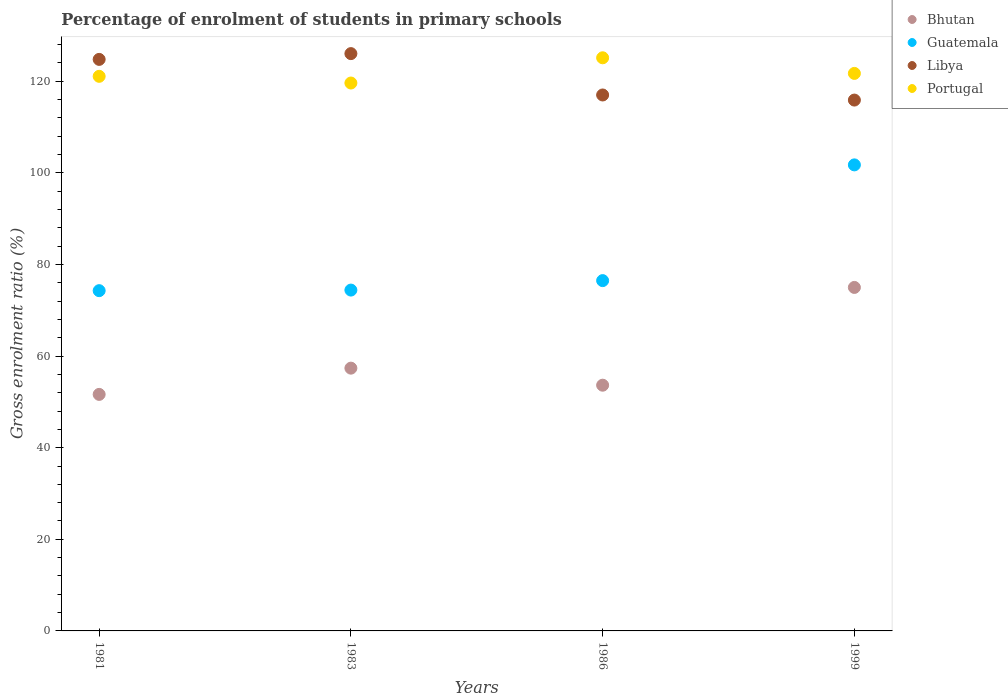How many different coloured dotlines are there?
Provide a succinct answer. 4. Is the number of dotlines equal to the number of legend labels?
Give a very brief answer. Yes. What is the percentage of students enrolled in primary schools in Bhutan in 1981?
Provide a short and direct response. 51.64. Across all years, what is the maximum percentage of students enrolled in primary schools in Libya?
Provide a short and direct response. 126.03. Across all years, what is the minimum percentage of students enrolled in primary schools in Bhutan?
Provide a short and direct response. 51.64. In which year was the percentage of students enrolled in primary schools in Bhutan maximum?
Make the answer very short. 1999. What is the total percentage of students enrolled in primary schools in Guatemala in the graph?
Your response must be concise. 326.91. What is the difference between the percentage of students enrolled in primary schools in Portugal in 1981 and that in 1983?
Keep it short and to the point. 1.46. What is the difference between the percentage of students enrolled in primary schools in Libya in 1981 and the percentage of students enrolled in primary schools in Bhutan in 1999?
Provide a short and direct response. 49.78. What is the average percentage of students enrolled in primary schools in Libya per year?
Give a very brief answer. 120.92. In the year 1986, what is the difference between the percentage of students enrolled in primary schools in Portugal and percentage of students enrolled in primary schools in Libya?
Make the answer very short. 8.12. What is the ratio of the percentage of students enrolled in primary schools in Libya in 1981 to that in 1999?
Your answer should be very brief. 1.08. Is the percentage of students enrolled in primary schools in Bhutan in 1983 less than that in 1999?
Your response must be concise. Yes. Is the difference between the percentage of students enrolled in primary schools in Portugal in 1986 and 1999 greater than the difference between the percentage of students enrolled in primary schools in Libya in 1986 and 1999?
Provide a short and direct response. Yes. What is the difference between the highest and the second highest percentage of students enrolled in primary schools in Bhutan?
Provide a short and direct response. 17.62. What is the difference between the highest and the lowest percentage of students enrolled in primary schools in Bhutan?
Give a very brief answer. 23.35. How many dotlines are there?
Keep it short and to the point. 4. How many years are there in the graph?
Your answer should be very brief. 4. Are the values on the major ticks of Y-axis written in scientific E-notation?
Make the answer very short. No. Does the graph contain any zero values?
Offer a very short reply. No. Where does the legend appear in the graph?
Give a very brief answer. Top right. How many legend labels are there?
Make the answer very short. 4. What is the title of the graph?
Offer a terse response. Percentage of enrolment of students in primary schools. What is the label or title of the X-axis?
Offer a terse response. Years. What is the label or title of the Y-axis?
Provide a short and direct response. Gross enrolment ratio (%). What is the Gross enrolment ratio (%) in Bhutan in 1981?
Provide a short and direct response. 51.64. What is the Gross enrolment ratio (%) of Guatemala in 1981?
Your answer should be compact. 74.28. What is the Gross enrolment ratio (%) of Libya in 1981?
Provide a short and direct response. 124.77. What is the Gross enrolment ratio (%) of Portugal in 1981?
Ensure brevity in your answer.  121.07. What is the Gross enrolment ratio (%) in Bhutan in 1983?
Offer a very short reply. 57.37. What is the Gross enrolment ratio (%) of Guatemala in 1983?
Give a very brief answer. 74.41. What is the Gross enrolment ratio (%) of Libya in 1983?
Give a very brief answer. 126.03. What is the Gross enrolment ratio (%) in Portugal in 1983?
Your answer should be compact. 119.61. What is the Gross enrolment ratio (%) of Bhutan in 1986?
Give a very brief answer. 53.64. What is the Gross enrolment ratio (%) of Guatemala in 1986?
Offer a terse response. 76.47. What is the Gross enrolment ratio (%) in Libya in 1986?
Keep it short and to the point. 117. What is the Gross enrolment ratio (%) in Portugal in 1986?
Your response must be concise. 125.12. What is the Gross enrolment ratio (%) in Bhutan in 1999?
Provide a short and direct response. 74.99. What is the Gross enrolment ratio (%) of Guatemala in 1999?
Provide a succinct answer. 101.74. What is the Gross enrolment ratio (%) in Libya in 1999?
Your answer should be very brief. 115.89. What is the Gross enrolment ratio (%) of Portugal in 1999?
Your answer should be compact. 121.71. Across all years, what is the maximum Gross enrolment ratio (%) of Bhutan?
Offer a very short reply. 74.99. Across all years, what is the maximum Gross enrolment ratio (%) of Guatemala?
Provide a short and direct response. 101.74. Across all years, what is the maximum Gross enrolment ratio (%) of Libya?
Offer a very short reply. 126.03. Across all years, what is the maximum Gross enrolment ratio (%) of Portugal?
Give a very brief answer. 125.12. Across all years, what is the minimum Gross enrolment ratio (%) of Bhutan?
Provide a short and direct response. 51.64. Across all years, what is the minimum Gross enrolment ratio (%) of Guatemala?
Your response must be concise. 74.28. Across all years, what is the minimum Gross enrolment ratio (%) of Libya?
Your answer should be compact. 115.89. Across all years, what is the minimum Gross enrolment ratio (%) in Portugal?
Ensure brevity in your answer.  119.61. What is the total Gross enrolment ratio (%) of Bhutan in the graph?
Offer a very short reply. 237.63. What is the total Gross enrolment ratio (%) of Guatemala in the graph?
Your response must be concise. 326.91. What is the total Gross enrolment ratio (%) in Libya in the graph?
Keep it short and to the point. 483.7. What is the total Gross enrolment ratio (%) in Portugal in the graph?
Offer a terse response. 487.52. What is the difference between the Gross enrolment ratio (%) of Bhutan in 1981 and that in 1983?
Your answer should be compact. -5.73. What is the difference between the Gross enrolment ratio (%) of Guatemala in 1981 and that in 1983?
Give a very brief answer. -0.13. What is the difference between the Gross enrolment ratio (%) in Libya in 1981 and that in 1983?
Your answer should be compact. -1.26. What is the difference between the Gross enrolment ratio (%) of Portugal in 1981 and that in 1983?
Provide a short and direct response. 1.46. What is the difference between the Gross enrolment ratio (%) of Bhutan in 1981 and that in 1986?
Keep it short and to the point. -2.01. What is the difference between the Gross enrolment ratio (%) of Guatemala in 1981 and that in 1986?
Make the answer very short. -2.19. What is the difference between the Gross enrolment ratio (%) in Libya in 1981 and that in 1986?
Offer a very short reply. 7.77. What is the difference between the Gross enrolment ratio (%) in Portugal in 1981 and that in 1986?
Offer a very short reply. -4.05. What is the difference between the Gross enrolment ratio (%) of Bhutan in 1981 and that in 1999?
Keep it short and to the point. -23.35. What is the difference between the Gross enrolment ratio (%) in Guatemala in 1981 and that in 1999?
Provide a short and direct response. -27.46. What is the difference between the Gross enrolment ratio (%) in Libya in 1981 and that in 1999?
Make the answer very short. 8.88. What is the difference between the Gross enrolment ratio (%) in Portugal in 1981 and that in 1999?
Your answer should be compact. -0.64. What is the difference between the Gross enrolment ratio (%) in Bhutan in 1983 and that in 1986?
Keep it short and to the point. 3.72. What is the difference between the Gross enrolment ratio (%) of Guatemala in 1983 and that in 1986?
Give a very brief answer. -2.07. What is the difference between the Gross enrolment ratio (%) in Libya in 1983 and that in 1986?
Offer a terse response. 9.03. What is the difference between the Gross enrolment ratio (%) of Portugal in 1983 and that in 1986?
Offer a very short reply. -5.51. What is the difference between the Gross enrolment ratio (%) in Bhutan in 1983 and that in 1999?
Your response must be concise. -17.62. What is the difference between the Gross enrolment ratio (%) of Guatemala in 1983 and that in 1999?
Provide a succinct answer. -27.33. What is the difference between the Gross enrolment ratio (%) in Libya in 1983 and that in 1999?
Offer a very short reply. 10.14. What is the difference between the Gross enrolment ratio (%) of Portugal in 1983 and that in 1999?
Provide a short and direct response. -2.1. What is the difference between the Gross enrolment ratio (%) in Bhutan in 1986 and that in 1999?
Offer a very short reply. -21.34. What is the difference between the Gross enrolment ratio (%) of Guatemala in 1986 and that in 1999?
Provide a short and direct response. -25.27. What is the difference between the Gross enrolment ratio (%) of Libya in 1986 and that in 1999?
Keep it short and to the point. 1.11. What is the difference between the Gross enrolment ratio (%) in Portugal in 1986 and that in 1999?
Provide a short and direct response. 3.41. What is the difference between the Gross enrolment ratio (%) of Bhutan in 1981 and the Gross enrolment ratio (%) of Guatemala in 1983?
Offer a terse response. -22.77. What is the difference between the Gross enrolment ratio (%) in Bhutan in 1981 and the Gross enrolment ratio (%) in Libya in 1983?
Provide a short and direct response. -74.4. What is the difference between the Gross enrolment ratio (%) in Bhutan in 1981 and the Gross enrolment ratio (%) in Portugal in 1983?
Your answer should be compact. -67.98. What is the difference between the Gross enrolment ratio (%) in Guatemala in 1981 and the Gross enrolment ratio (%) in Libya in 1983?
Give a very brief answer. -51.75. What is the difference between the Gross enrolment ratio (%) in Guatemala in 1981 and the Gross enrolment ratio (%) in Portugal in 1983?
Offer a terse response. -45.33. What is the difference between the Gross enrolment ratio (%) in Libya in 1981 and the Gross enrolment ratio (%) in Portugal in 1983?
Keep it short and to the point. 5.16. What is the difference between the Gross enrolment ratio (%) in Bhutan in 1981 and the Gross enrolment ratio (%) in Guatemala in 1986?
Offer a terse response. -24.84. What is the difference between the Gross enrolment ratio (%) of Bhutan in 1981 and the Gross enrolment ratio (%) of Libya in 1986?
Give a very brief answer. -65.37. What is the difference between the Gross enrolment ratio (%) of Bhutan in 1981 and the Gross enrolment ratio (%) of Portugal in 1986?
Your answer should be very brief. -73.48. What is the difference between the Gross enrolment ratio (%) in Guatemala in 1981 and the Gross enrolment ratio (%) in Libya in 1986?
Offer a terse response. -42.72. What is the difference between the Gross enrolment ratio (%) of Guatemala in 1981 and the Gross enrolment ratio (%) of Portugal in 1986?
Offer a very short reply. -50.84. What is the difference between the Gross enrolment ratio (%) in Libya in 1981 and the Gross enrolment ratio (%) in Portugal in 1986?
Offer a very short reply. -0.35. What is the difference between the Gross enrolment ratio (%) of Bhutan in 1981 and the Gross enrolment ratio (%) of Guatemala in 1999?
Offer a very short reply. -50.11. What is the difference between the Gross enrolment ratio (%) in Bhutan in 1981 and the Gross enrolment ratio (%) in Libya in 1999?
Offer a terse response. -64.25. What is the difference between the Gross enrolment ratio (%) in Bhutan in 1981 and the Gross enrolment ratio (%) in Portugal in 1999?
Provide a succinct answer. -70.08. What is the difference between the Gross enrolment ratio (%) in Guatemala in 1981 and the Gross enrolment ratio (%) in Libya in 1999?
Give a very brief answer. -41.61. What is the difference between the Gross enrolment ratio (%) of Guatemala in 1981 and the Gross enrolment ratio (%) of Portugal in 1999?
Your answer should be very brief. -47.43. What is the difference between the Gross enrolment ratio (%) of Libya in 1981 and the Gross enrolment ratio (%) of Portugal in 1999?
Give a very brief answer. 3.06. What is the difference between the Gross enrolment ratio (%) of Bhutan in 1983 and the Gross enrolment ratio (%) of Guatemala in 1986?
Provide a succinct answer. -19.11. What is the difference between the Gross enrolment ratio (%) of Bhutan in 1983 and the Gross enrolment ratio (%) of Libya in 1986?
Offer a terse response. -59.64. What is the difference between the Gross enrolment ratio (%) in Bhutan in 1983 and the Gross enrolment ratio (%) in Portugal in 1986?
Your answer should be compact. -67.75. What is the difference between the Gross enrolment ratio (%) of Guatemala in 1983 and the Gross enrolment ratio (%) of Libya in 1986?
Provide a short and direct response. -42.59. What is the difference between the Gross enrolment ratio (%) in Guatemala in 1983 and the Gross enrolment ratio (%) in Portugal in 1986?
Keep it short and to the point. -50.71. What is the difference between the Gross enrolment ratio (%) in Libya in 1983 and the Gross enrolment ratio (%) in Portugal in 1986?
Give a very brief answer. 0.91. What is the difference between the Gross enrolment ratio (%) in Bhutan in 1983 and the Gross enrolment ratio (%) in Guatemala in 1999?
Ensure brevity in your answer.  -44.38. What is the difference between the Gross enrolment ratio (%) of Bhutan in 1983 and the Gross enrolment ratio (%) of Libya in 1999?
Provide a succinct answer. -58.52. What is the difference between the Gross enrolment ratio (%) of Bhutan in 1983 and the Gross enrolment ratio (%) of Portugal in 1999?
Provide a short and direct response. -64.35. What is the difference between the Gross enrolment ratio (%) of Guatemala in 1983 and the Gross enrolment ratio (%) of Libya in 1999?
Offer a terse response. -41.48. What is the difference between the Gross enrolment ratio (%) in Guatemala in 1983 and the Gross enrolment ratio (%) in Portugal in 1999?
Provide a short and direct response. -47.3. What is the difference between the Gross enrolment ratio (%) in Libya in 1983 and the Gross enrolment ratio (%) in Portugal in 1999?
Your response must be concise. 4.32. What is the difference between the Gross enrolment ratio (%) of Bhutan in 1986 and the Gross enrolment ratio (%) of Guatemala in 1999?
Provide a short and direct response. -48.1. What is the difference between the Gross enrolment ratio (%) in Bhutan in 1986 and the Gross enrolment ratio (%) in Libya in 1999?
Offer a very short reply. -62.25. What is the difference between the Gross enrolment ratio (%) in Bhutan in 1986 and the Gross enrolment ratio (%) in Portugal in 1999?
Offer a very short reply. -68.07. What is the difference between the Gross enrolment ratio (%) of Guatemala in 1986 and the Gross enrolment ratio (%) of Libya in 1999?
Your answer should be very brief. -39.42. What is the difference between the Gross enrolment ratio (%) of Guatemala in 1986 and the Gross enrolment ratio (%) of Portugal in 1999?
Your answer should be very brief. -45.24. What is the difference between the Gross enrolment ratio (%) of Libya in 1986 and the Gross enrolment ratio (%) of Portugal in 1999?
Offer a very short reply. -4.71. What is the average Gross enrolment ratio (%) of Bhutan per year?
Provide a short and direct response. 59.41. What is the average Gross enrolment ratio (%) of Guatemala per year?
Provide a short and direct response. 81.73. What is the average Gross enrolment ratio (%) in Libya per year?
Make the answer very short. 120.92. What is the average Gross enrolment ratio (%) of Portugal per year?
Make the answer very short. 121.88. In the year 1981, what is the difference between the Gross enrolment ratio (%) in Bhutan and Gross enrolment ratio (%) in Guatemala?
Your answer should be very brief. -22.65. In the year 1981, what is the difference between the Gross enrolment ratio (%) in Bhutan and Gross enrolment ratio (%) in Libya?
Provide a short and direct response. -73.13. In the year 1981, what is the difference between the Gross enrolment ratio (%) in Bhutan and Gross enrolment ratio (%) in Portugal?
Provide a succinct answer. -69.44. In the year 1981, what is the difference between the Gross enrolment ratio (%) of Guatemala and Gross enrolment ratio (%) of Libya?
Offer a very short reply. -50.49. In the year 1981, what is the difference between the Gross enrolment ratio (%) in Guatemala and Gross enrolment ratio (%) in Portugal?
Your answer should be very brief. -46.79. In the year 1981, what is the difference between the Gross enrolment ratio (%) of Libya and Gross enrolment ratio (%) of Portugal?
Your answer should be very brief. 3.7. In the year 1983, what is the difference between the Gross enrolment ratio (%) in Bhutan and Gross enrolment ratio (%) in Guatemala?
Keep it short and to the point. -17.04. In the year 1983, what is the difference between the Gross enrolment ratio (%) of Bhutan and Gross enrolment ratio (%) of Libya?
Give a very brief answer. -68.67. In the year 1983, what is the difference between the Gross enrolment ratio (%) of Bhutan and Gross enrolment ratio (%) of Portugal?
Keep it short and to the point. -62.25. In the year 1983, what is the difference between the Gross enrolment ratio (%) in Guatemala and Gross enrolment ratio (%) in Libya?
Your answer should be very brief. -51.62. In the year 1983, what is the difference between the Gross enrolment ratio (%) in Guatemala and Gross enrolment ratio (%) in Portugal?
Give a very brief answer. -45.2. In the year 1983, what is the difference between the Gross enrolment ratio (%) of Libya and Gross enrolment ratio (%) of Portugal?
Ensure brevity in your answer.  6.42. In the year 1986, what is the difference between the Gross enrolment ratio (%) of Bhutan and Gross enrolment ratio (%) of Guatemala?
Offer a very short reply. -22.83. In the year 1986, what is the difference between the Gross enrolment ratio (%) of Bhutan and Gross enrolment ratio (%) of Libya?
Your answer should be compact. -63.36. In the year 1986, what is the difference between the Gross enrolment ratio (%) in Bhutan and Gross enrolment ratio (%) in Portugal?
Your answer should be very brief. -71.48. In the year 1986, what is the difference between the Gross enrolment ratio (%) of Guatemala and Gross enrolment ratio (%) of Libya?
Ensure brevity in your answer.  -40.53. In the year 1986, what is the difference between the Gross enrolment ratio (%) in Guatemala and Gross enrolment ratio (%) in Portugal?
Give a very brief answer. -48.65. In the year 1986, what is the difference between the Gross enrolment ratio (%) of Libya and Gross enrolment ratio (%) of Portugal?
Your answer should be very brief. -8.12. In the year 1999, what is the difference between the Gross enrolment ratio (%) in Bhutan and Gross enrolment ratio (%) in Guatemala?
Your answer should be compact. -26.75. In the year 1999, what is the difference between the Gross enrolment ratio (%) in Bhutan and Gross enrolment ratio (%) in Libya?
Your response must be concise. -40.9. In the year 1999, what is the difference between the Gross enrolment ratio (%) of Bhutan and Gross enrolment ratio (%) of Portugal?
Offer a terse response. -46.72. In the year 1999, what is the difference between the Gross enrolment ratio (%) of Guatemala and Gross enrolment ratio (%) of Libya?
Offer a terse response. -14.15. In the year 1999, what is the difference between the Gross enrolment ratio (%) in Guatemala and Gross enrolment ratio (%) in Portugal?
Your response must be concise. -19.97. In the year 1999, what is the difference between the Gross enrolment ratio (%) of Libya and Gross enrolment ratio (%) of Portugal?
Offer a terse response. -5.82. What is the ratio of the Gross enrolment ratio (%) of Bhutan in 1981 to that in 1983?
Your response must be concise. 0.9. What is the ratio of the Gross enrolment ratio (%) of Guatemala in 1981 to that in 1983?
Your answer should be compact. 1. What is the ratio of the Gross enrolment ratio (%) in Libya in 1981 to that in 1983?
Ensure brevity in your answer.  0.99. What is the ratio of the Gross enrolment ratio (%) in Portugal in 1981 to that in 1983?
Give a very brief answer. 1.01. What is the ratio of the Gross enrolment ratio (%) in Bhutan in 1981 to that in 1986?
Ensure brevity in your answer.  0.96. What is the ratio of the Gross enrolment ratio (%) in Guatemala in 1981 to that in 1986?
Provide a succinct answer. 0.97. What is the ratio of the Gross enrolment ratio (%) of Libya in 1981 to that in 1986?
Provide a short and direct response. 1.07. What is the ratio of the Gross enrolment ratio (%) of Bhutan in 1981 to that in 1999?
Give a very brief answer. 0.69. What is the ratio of the Gross enrolment ratio (%) of Guatemala in 1981 to that in 1999?
Make the answer very short. 0.73. What is the ratio of the Gross enrolment ratio (%) in Libya in 1981 to that in 1999?
Ensure brevity in your answer.  1.08. What is the ratio of the Gross enrolment ratio (%) in Bhutan in 1983 to that in 1986?
Your answer should be compact. 1.07. What is the ratio of the Gross enrolment ratio (%) in Libya in 1983 to that in 1986?
Make the answer very short. 1.08. What is the ratio of the Gross enrolment ratio (%) in Portugal in 1983 to that in 1986?
Ensure brevity in your answer.  0.96. What is the ratio of the Gross enrolment ratio (%) of Bhutan in 1983 to that in 1999?
Ensure brevity in your answer.  0.77. What is the ratio of the Gross enrolment ratio (%) of Guatemala in 1983 to that in 1999?
Your response must be concise. 0.73. What is the ratio of the Gross enrolment ratio (%) in Libya in 1983 to that in 1999?
Keep it short and to the point. 1.09. What is the ratio of the Gross enrolment ratio (%) in Portugal in 1983 to that in 1999?
Your answer should be compact. 0.98. What is the ratio of the Gross enrolment ratio (%) in Bhutan in 1986 to that in 1999?
Offer a very short reply. 0.72. What is the ratio of the Gross enrolment ratio (%) of Guatemala in 1986 to that in 1999?
Provide a succinct answer. 0.75. What is the ratio of the Gross enrolment ratio (%) in Libya in 1986 to that in 1999?
Your answer should be compact. 1.01. What is the ratio of the Gross enrolment ratio (%) in Portugal in 1986 to that in 1999?
Give a very brief answer. 1.03. What is the difference between the highest and the second highest Gross enrolment ratio (%) in Bhutan?
Give a very brief answer. 17.62. What is the difference between the highest and the second highest Gross enrolment ratio (%) in Guatemala?
Offer a terse response. 25.27. What is the difference between the highest and the second highest Gross enrolment ratio (%) in Libya?
Your answer should be compact. 1.26. What is the difference between the highest and the second highest Gross enrolment ratio (%) of Portugal?
Offer a very short reply. 3.41. What is the difference between the highest and the lowest Gross enrolment ratio (%) in Bhutan?
Provide a succinct answer. 23.35. What is the difference between the highest and the lowest Gross enrolment ratio (%) in Guatemala?
Your answer should be compact. 27.46. What is the difference between the highest and the lowest Gross enrolment ratio (%) in Libya?
Your answer should be compact. 10.14. What is the difference between the highest and the lowest Gross enrolment ratio (%) in Portugal?
Offer a terse response. 5.51. 